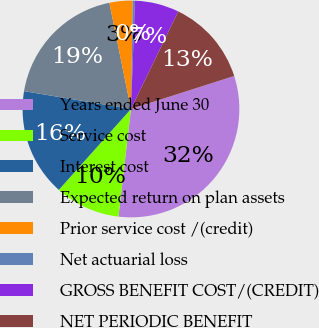Convert chart. <chart><loc_0><loc_0><loc_500><loc_500><pie_chart><fcel>Years ended June 30<fcel>Service cost<fcel>Interest cost<fcel>Expected return on plan assets<fcel>Prior service cost /(credit)<fcel>Net actuarial loss<fcel>GROSS BENEFIT COST/(CREDIT)<fcel>NET PERIODIC BENEFIT<nl><fcel>31.76%<fcel>9.75%<fcel>16.04%<fcel>19.18%<fcel>3.46%<fcel>0.32%<fcel>6.6%<fcel>12.89%<nl></chart> 